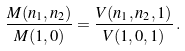Convert formula to latex. <formula><loc_0><loc_0><loc_500><loc_500>\frac { M ( n _ { 1 } , n _ { 2 } ) } { M ( 1 , 0 ) } = \frac { V ( n _ { 1 } , n _ { 2 } , 1 ) } { V ( 1 , 0 , 1 ) } \, .</formula> 